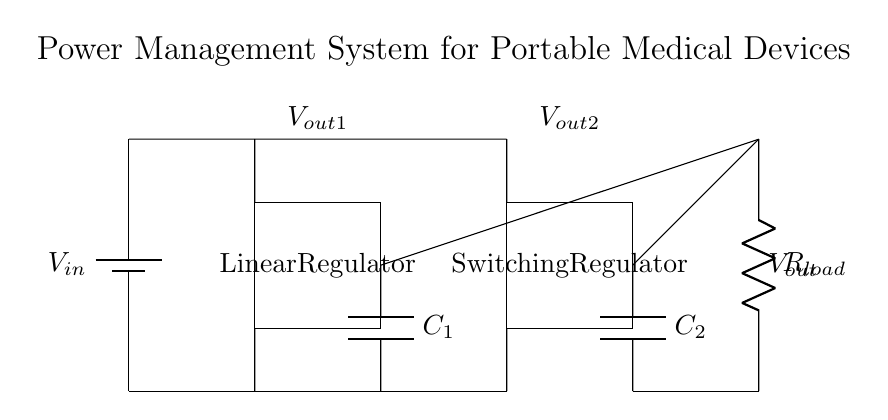What are the two types of regulators in this circuit? The circuit diagram displays a linear regulator and a switching regulator. These components are specifically labeled in the diagram.
Answer: linear regulator, switching regulator What is the function of the capacitor labeled C1? C1 is used to smooth the output voltage from the linear regulator, providing stability and filtering of voltage fluctuations. The diagram indicates its placement after the linear regulator.
Answer: voltage smoothing What is the role of the load resistor R_load? R_load represents the load that the power management system is supplying voltage to, mimicking a device in operation. The circuit connects this load to the outputs of both regulators.
Answer: load How many output voltages does this circuit provide? The circuit provides two output voltages, indicated by V_out1 from the linear regulator and V_out2 from the switching regulator. Both outputs are connected to R_load.
Answer: two Which output capacitor is connected to the switching regulator? The capacitor labeled C2 is connected to the output of the switching regulator to stabilize its output voltage. The position of C2 in the diagram confirms this connection.
Answer: C2 What voltage levels are indicated in the circuit by V_out1 and V_out2? V_out1 and V_out2 represent the output voltage levels obtained from the linear regulator and switching regulator, respectively. However, the exact voltage values aren't provided in the diagram.
Answer: unspecified levels What type of power management technique does this circuit utilize? The circuit employs a hybrid power management technique by utilizing both linear and switching regulation to optimize efficiency for portable medical devices. This is evident from its structure integrating both types of regulators.
Answer: hybrid regulation 